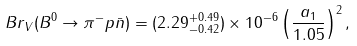Convert formula to latex. <formula><loc_0><loc_0><loc_500><loc_500>B r _ { V } ( B ^ { 0 } \to \pi ^ { - } p \bar { n } ) = ( 2 . 2 9 ^ { + 0 . 4 9 } _ { - 0 . 4 2 } ) \times 1 0 ^ { - 6 } \left ( \frac { a _ { 1 } } { 1 . 0 5 } \right ) ^ { 2 } ,</formula> 